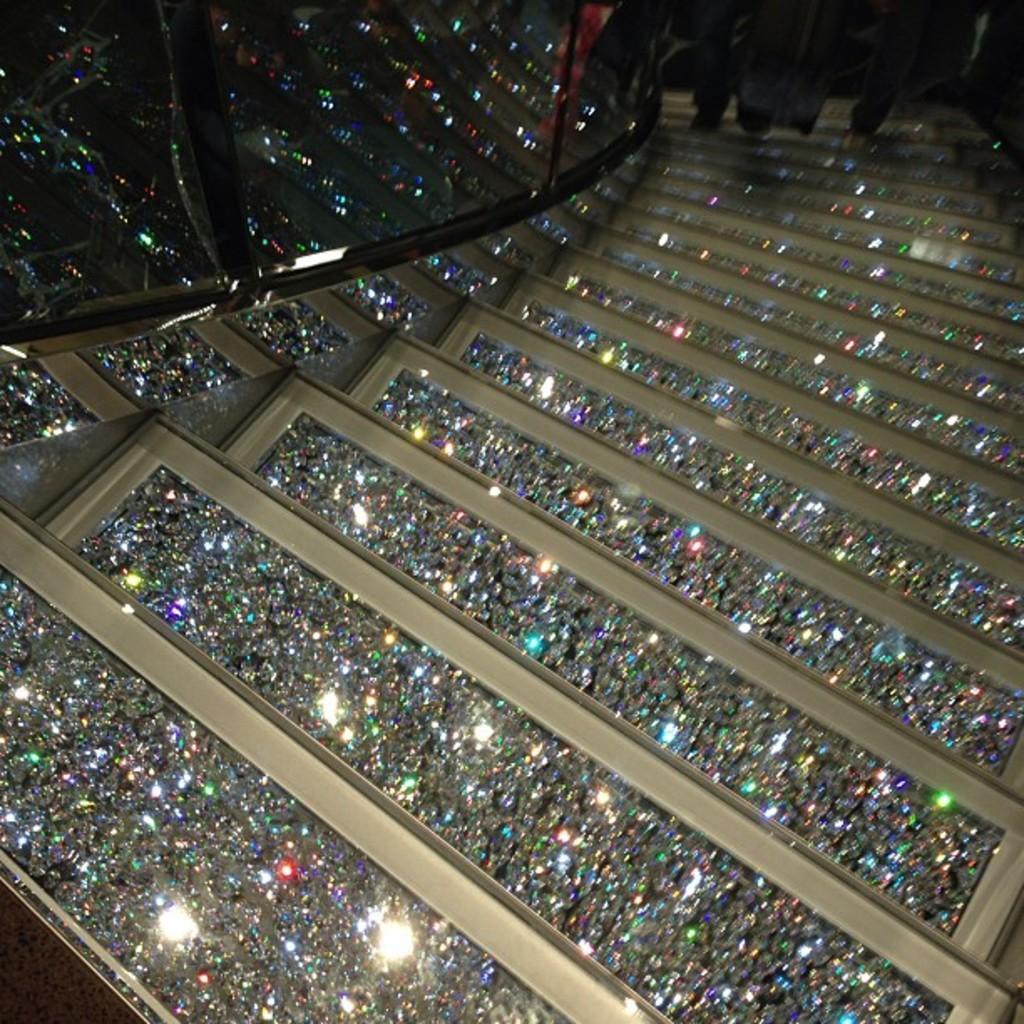Can you describe this image briefly? In this image we can see stairs. At the top of the image, we can see railing and people. 